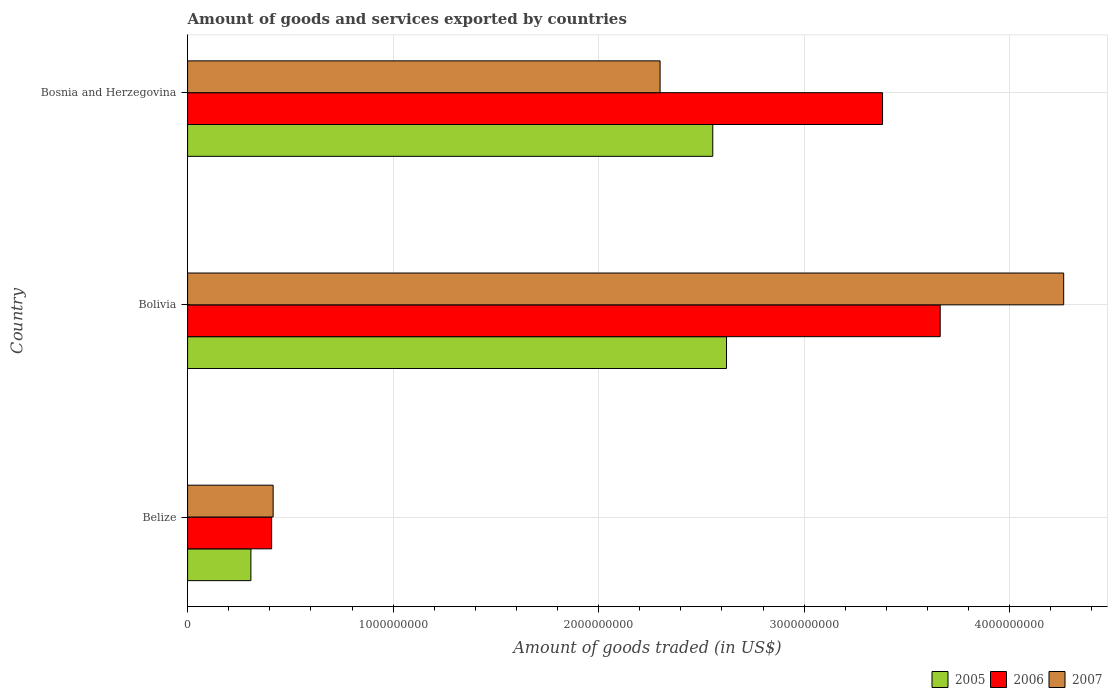How many different coloured bars are there?
Your answer should be compact. 3. How many groups of bars are there?
Ensure brevity in your answer.  3. Are the number of bars per tick equal to the number of legend labels?
Offer a very short reply. Yes. How many bars are there on the 1st tick from the top?
Give a very brief answer. 3. What is the label of the 2nd group of bars from the top?
Offer a terse response. Bolivia. In how many cases, is the number of bars for a given country not equal to the number of legend labels?
Give a very brief answer. 0. What is the total amount of goods and services exported in 2007 in Belize?
Your answer should be compact. 4.16e+08. Across all countries, what is the maximum total amount of goods and services exported in 2006?
Your answer should be very brief. 3.66e+09. Across all countries, what is the minimum total amount of goods and services exported in 2005?
Provide a short and direct response. 3.08e+08. In which country was the total amount of goods and services exported in 2005 maximum?
Offer a very short reply. Bolivia. In which country was the total amount of goods and services exported in 2006 minimum?
Ensure brevity in your answer.  Belize. What is the total total amount of goods and services exported in 2006 in the graph?
Offer a very short reply. 7.45e+09. What is the difference between the total amount of goods and services exported in 2006 in Belize and that in Bosnia and Herzegovina?
Offer a very short reply. -2.97e+09. What is the difference between the total amount of goods and services exported in 2006 in Belize and the total amount of goods and services exported in 2005 in Bosnia and Herzegovina?
Make the answer very short. -2.15e+09. What is the average total amount of goods and services exported in 2005 per country?
Give a very brief answer. 1.83e+09. What is the difference between the total amount of goods and services exported in 2007 and total amount of goods and services exported in 2005 in Bolivia?
Keep it short and to the point. 1.64e+09. What is the ratio of the total amount of goods and services exported in 2007 in Belize to that in Bolivia?
Offer a very short reply. 0.1. Is the total amount of goods and services exported in 2006 in Belize less than that in Bosnia and Herzegovina?
Provide a succinct answer. Yes. What is the difference between the highest and the second highest total amount of goods and services exported in 2006?
Offer a terse response. 2.81e+08. What is the difference between the highest and the lowest total amount of goods and services exported in 2007?
Your answer should be very brief. 3.85e+09. In how many countries, is the total amount of goods and services exported in 2006 greater than the average total amount of goods and services exported in 2006 taken over all countries?
Your response must be concise. 2. Is the sum of the total amount of goods and services exported in 2007 in Belize and Bolivia greater than the maximum total amount of goods and services exported in 2006 across all countries?
Keep it short and to the point. Yes. What does the 1st bar from the bottom in Belize represents?
Give a very brief answer. 2005. Is it the case that in every country, the sum of the total amount of goods and services exported in 2006 and total amount of goods and services exported in 2005 is greater than the total amount of goods and services exported in 2007?
Offer a terse response. Yes. How many bars are there?
Ensure brevity in your answer.  9. How many countries are there in the graph?
Provide a succinct answer. 3. What is the difference between two consecutive major ticks on the X-axis?
Give a very brief answer. 1.00e+09. Are the values on the major ticks of X-axis written in scientific E-notation?
Your response must be concise. No. Does the graph contain any zero values?
Offer a terse response. No. Does the graph contain grids?
Provide a short and direct response. Yes. Where does the legend appear in the graph?
Provide a short and direct response. Bottom right. How are the legend labels stacked?
Your answer should be very brief. Horizontal. What is the title of the graph?
Give a very brief answer. Amount of goods and services exported by countries. Does "1982" appear as one of the legend labels in the graph?
Offer a very short reply. No. What is the label or title of the X-axis?
Offer a terse response. Amount of goods traded (in US$). What is the Amount of goods traded (in US$) in 2005 in Belize?
Give a very brief answer. 3.08e+08. What is the Amount of goods traded (in US$) of 2006 in Belize?
Offer a terse response. 4.09e+08. What is the Amount of goods traded (in US$) in 2007 in Belize?
Your answer should be compact. 4.16e+08. What is the Amount of goods traded (in US$) of 2005 in Bolivia?
Offer a very short reply. 2.62e+09. What is the Amount of goods traded (in US$) in 2006 in Bolivia?
Your answer should be very brief. 3.66e+09. What is the Amount of goods traded (in US$) of 2007 in Bolivia?
Your response must be concise. 4.26e+09. What is the Amount of goods traded (in US$) in 2005 in Bosnia and Herzegovina?
Your answer should be compact. 2.56e+09. What is the Amount of goods traded (in US$) of 2006 in Bosnia and Herzegovina?
Provide a short and direct response. 3.38e+09. What is the Amount of goods traded (in US$) of 2007 in Bosnia and Herzegovina?
Your answer should be very brief. 2.30e+09. Across all countries, what is the maximum Amount of goods traded (in US$) of 2005?
Make the answer very short. 2.62e+09. Across all countries, what is the maximum Amount of goods traded (in US$) of 2006?
Ensure brevity in your answer.  3.66e+09. Across all countries, what is the maximum Amount of goods traded (in US$) of 2007?
Offer a terse response. 4.26e+09. Across all countries, what is the minimum Amount of goods traded (in US$) of 2005?
Provide a short and direct response. 3.08e+08. Across all countries, what is the minimum Amount of goods traded (in US$) in 2006?
Provide a short and direct response. 4.09e+08. Across all countries, what is the minimum Amount of goods traded (in US$) of 2007?
Offer a very short reply. 4.16e+08. What is the total Amount of goods traded (in US$) of 2005 in the graph?
Your answer should be very brief. 5.49e+09. What is the total Amount of goods traded (in US$) in 2006 in the graph?
Your answer should be very brief. 7.45e+09. What is the total Amount of goods traded (in US$) in 2007 in the graph?
Provide a succinct answer. 6.98e+09. What is the difference between the Amount of goods traded (in US$) of 2005 in Belize and that in Bolivia?
Your answer should be very brief. -2.31e+09. What is the difference between the Amount of goods traded (in US$) of 2006 in Belize and that in Bolivia?
Make the answer very short. -3.25e+09. What is the difference between the Amount of goods traded (in US$) in 2007 in Belize and that in Bolivia?
Offer a very short reply. -3.85e+09. What is the difference between the Amount of goods traded (in US$) in 2005 in Belize and that in Bosnia and Herzegovina?
Offer a terse response. -2.25e+09. What is the difference between the Amount of goods traded (in US$) in 2006 in Belize and that in Bosnia and Herzegovina?
Provide a short and direct response. -2.97e+09. What is the difference between the Amount of goods traded (in US$) in 2007 in Belize and that in Bosnia and Herzegovina?
Your response must be concise. -1.88e+09. What is the difference between the Amount of goods traded (in US$) of 2005 in Bolivia and that in Bosnia and Herzegovina?
Your answer should be compact. 6.69e+07. What is the difference between the Amount of goods traded (in US$) of 2006 in Bolivia and that in Bosnia and Herzegovina?
Provide a short and direct response. 2.81e+08. What is the difference between the Amount of goods traded (in US$) of 2007 in Bolivia and that in Bosnia and Herzegovina?
Offer a very short reply. 1.96e+09. What is the difference between the Amount of goods traded (in US$) of 2005 in Belize and the Amount of goods traded (in US$) of 2006 in Bolivia?
Provide a short and direct response. -3.35e+09. What is the difference between the Amount of goods traded (in US$) of 2005 in Belize and the Amount of goods traded (in US$) of 2007 in Bolivia?
Your response must be concise. -3.95e+09. What is the difference between the Amount of goods traded (in US$) of 2006 in Belize and the Amount of goods traded (in US$) of 2007 in Bolivia?
Offer a terse response. -3.85e+09. What is the difference between the Amount of goods traded (in US$) of 2005 in Belize and the Amount of goods traded (in US$) of 2006 in Bosnia and Herzegovina?
Make the answer very short. -3.07e+09. What is the difference between the Amount of goods traded (in US$) of 2005 in Belize and the Amount of goods traded (in US$) of 2007 in Bosnia and Herzegovina?
Provide a succinct answer. -1.99e+09. What is the difference between the Amount of goods traded (in US$) in 2006 in Belize and the Amount of goods traded (in US$) in 2007 in Bosnia and Herzegovina?
Your answer should be compact. -1.89e+09. What is the difference between the Amount of goods traded (in US$) of 2005 in Bolivia and the Amount of goods traded (in US$) of 2006 in Bosnia and Herzegovina?
Make the answer very short. -7.59e+08. What is the difference between the Amount of goods traded (in US$) of 2005 in Bolivia and the Amount of goods traded (in US$) of 2007 in Bosnia and Herzegovina?
Your answer should be very brief. 3.23e+08. What is the difference between the Amount of goods traded (in US$) in 2006 in Bolivia and the Amount of goods traded (in US$) in 2007 in Bosnia and Herzegovina?
Offer a terse response. 1.36e+09. What is the average Amount of goods traded (in US$) in 2005 per country?
Your response must be concise. 1.83e+09. What is the average Amount of goods traded (in US$) in 2006 per country?
Give a very brief answer. 2.48e+09. What is the average Amount of goods traded (in US$) in 2007 per country?
Make the answer very short. 2.33e+09. What is the difference between the Amount of goods traded (in US$) in 2005 and Amount of goods traded (in US$) in 2006 in Belize?
Offer a very short reply. -1.01e+08. What is the difference between the Amount of goods traded (in US$) in 2005 and Amount of goods traded (in US$) in 2007 in Belize?
Offer a very short reply. -1.08e+08. What is the difference between the Amount of goods traded (in US$) of 2006 and Amount of goods traded (in US$) of 2007 in Belize?
Ensure brevity in your answer.  -7.34e+06. What is the difference between the Amount of goods traded (in US$) in 2005 and Amount of goods traded (in US$) in 2006 in Bolivia?
Make the answer very short. -1.04e+09. What is the difference between the Amount of goods traded (in US$) of 2005 and Amount of goods traded (in US$) of 2007 in Bolivia?
Your answer should be compact. -1.64e+09. What is the difference between the Amount of goods traded (in US$) of 2006 and Amount of goods traded (in US$) of 2007 in Bolivia?
Your response must be concise. -6.01e+08. What is the difference between the Amount of goods traded (in US$) of 2005 and Amount of goods traded (in US$) of 2006 in Bosnia and Herzegovina?
Keep it short and to the point. -8.26e+08. What is the difference between the Amount of goods traded (in US$) in 2005 and Amount of goods traded (in US$) in 2007 in Bosnia and Herzegovina?
Give a very brief answer. 2.56e+08. What is the difference between the Amount of goods traded (in US$) of 2006 and Amount of goods traded (in US$) of 2007 in Bosnia and Herzegovina?
Offer a very short reply. 1.08e+09. What is the ratio of the Amount of goods traded (in US$) of 2005 in Belize to that in Bolivia?
Ensure brevity in your answer.  0.12. What is the ratio of the Amount of goods traded (in US$) in 2006 in Belize to that in Bolivia?
Provide a succinct answer. 0.11. What is the ratio of the Amount of goods traded (in US$) of 2007 in Belize to that in Bolivia?
Give a very brief answer. 0.1. What is the ratio of the Amount of goods traded (in US$) in 2005 in Belize to that in Bosnia and Herzegovina?
Your response must be concise. 0.12. What is the ratio of the Amount of goods traded (in US$) of 2006 in Belize to that in Bosnia and Herzegovina?
Give a very brief answer. 0.12. What is the ratio of the Amount of goods traded (in US$) in 2007 in Belize to that in Bosnia and Herzegovina?
Offer a very short reply. 0.18. What is the ratio of the Amount of goods traded (in US$) in 2005 in Bolivia to that in Bosnia and Herzegovina?
Offer a terse response. 1.03. What is the ratio of the Amount of goods traded (in US$) in 2006 in Bolivia to that in Bosnia and Herzegovina?
Make the answer very short. 1.08. What is the ratio of the Amount of goods traded (in US$) in 2007 in Bolivia to that in Bosnia and Herzegovina?
Keep it short and to the point. 1.85. What is the difference between the highest and the second highest Amount of goods traded (in US$) in 2005?
Keep it short and to the point. 6.69e+07. What is the difference between the highest and the second highest Amount of goods traded (in US$) of 2006?
Your answer should be very brief. 2.81e+08. What is the difference between the highest and the second highest Amount of goods traded (in US$) in 2007?
Offer a terse response. 1.96e+09. What is the difference between the highest and the lowest Amount of goods traded (in US$) of 2005?
Your response must be concise. 2.31e+09. What is the difference between the highest and the lowest Amount of goods traded (in US$) in 2006?
Keep it short and to the point. 3.25e+09. What is the difference between the highest and the lowest Amount of goods traded (in US$) in 2007?
Keep it short and to the point. 3.85e+09. 